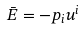Convert formula to latex. <formula><loc_0><loc_0><loc_500><loc_500>\bar { E } = - p _ { i } u ^ { i }</formula> 